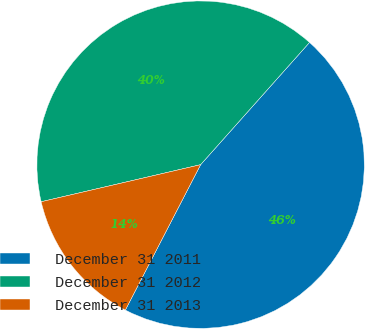Convert chart. <chart><loc_0><loc_0><loc_500><loc_500><pie_chart><fcel>December 31 2011<fcel>December 31 2012<fcel>December 31 2013<nl><fcel>46.02%<fcel>40.22%<fcel>13.76%<nl></chart> 